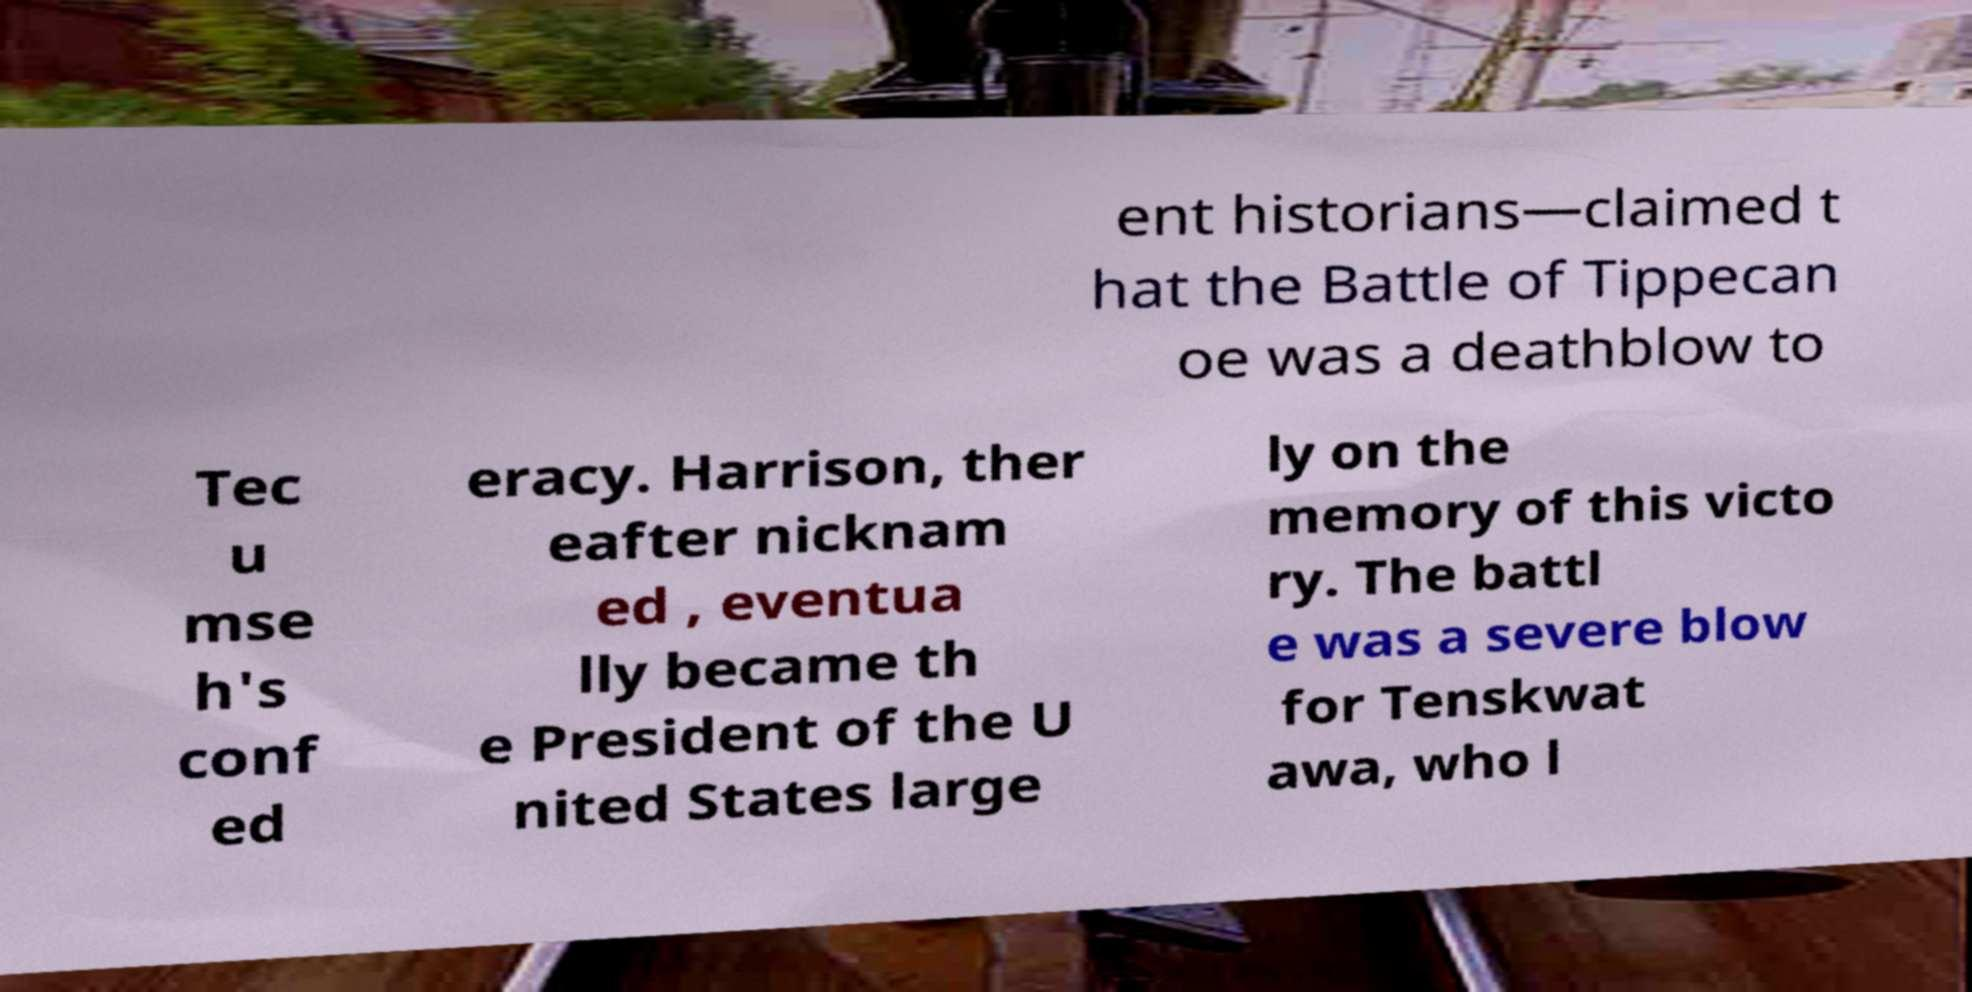For documentation purposes, I need the text within this image transcribed. Could you provide that? ent historians—claimed t hat the Battle of Tippecan oe was a deathblow to Tec u mse h's conf ed eracy. Harrison, ther eafter nicknam ed , eventua lly became th e President of the U nited States large ly on the memory of this victo ry. The battl e was a severe blow for Tenskwat awa, who l 